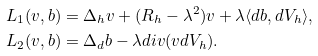<formula> <loc_0><loc_0><loc_500><loc_500>L _ { 1 } ( v , b ) & = \Delta _ { h } v + ( R _ { h } - \lambda ^ { 2 } ) v + \lambda \langle d b , d V _ { h } \rangle , \\ L _ { 2 } ( v , b ) & = \Delta _ { d } b - \lambda d i v ( v d V _ { h } ) .</formula> 